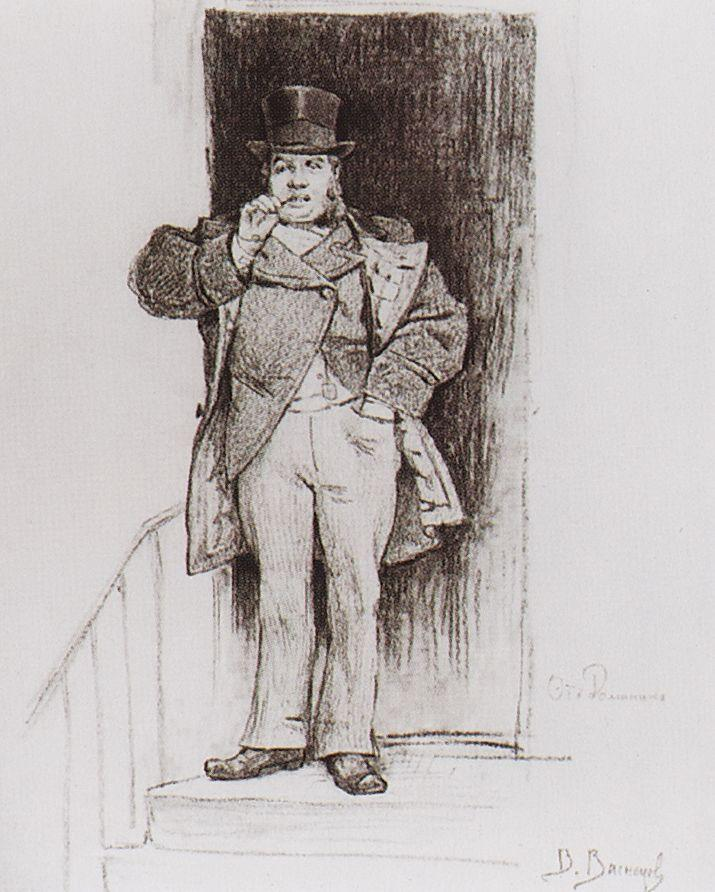What might be the historical context or period for this sketch? This sketch likely dates back to the late 19th century, a time characterized by a focus on formal attire and social status, evidenced by the man's attire. His outfit and cane suggest he could be a gentleman of some standing in society during that period, possibly a businessman or a figure of social significance. 